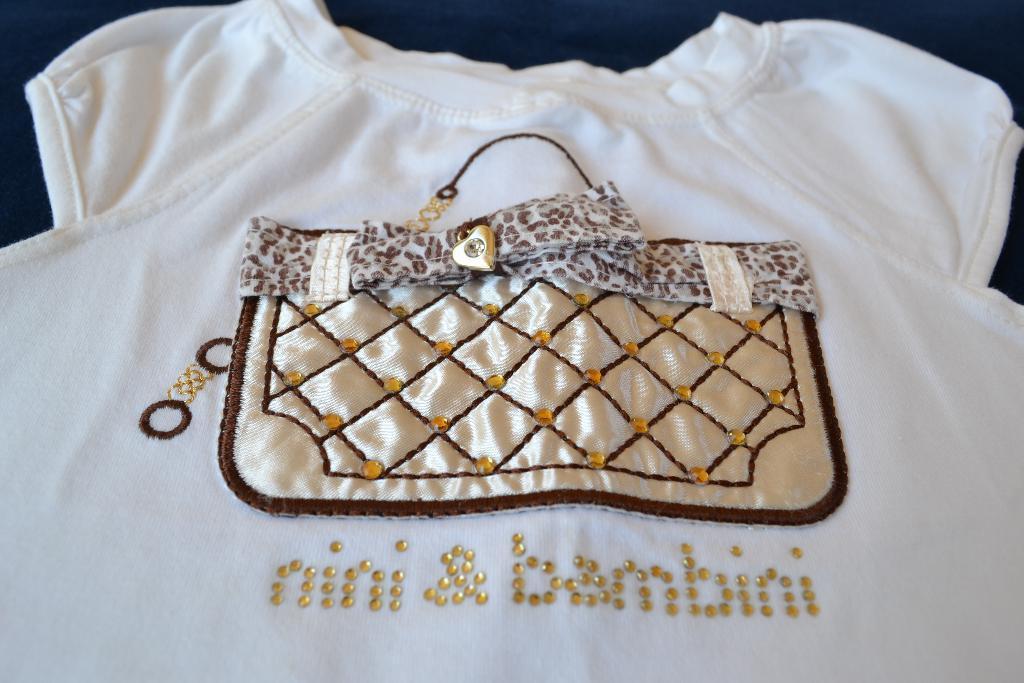Could you give a brief overview of what you see in this image? In the picture I can see a white color dress which has a design and something written on it. 